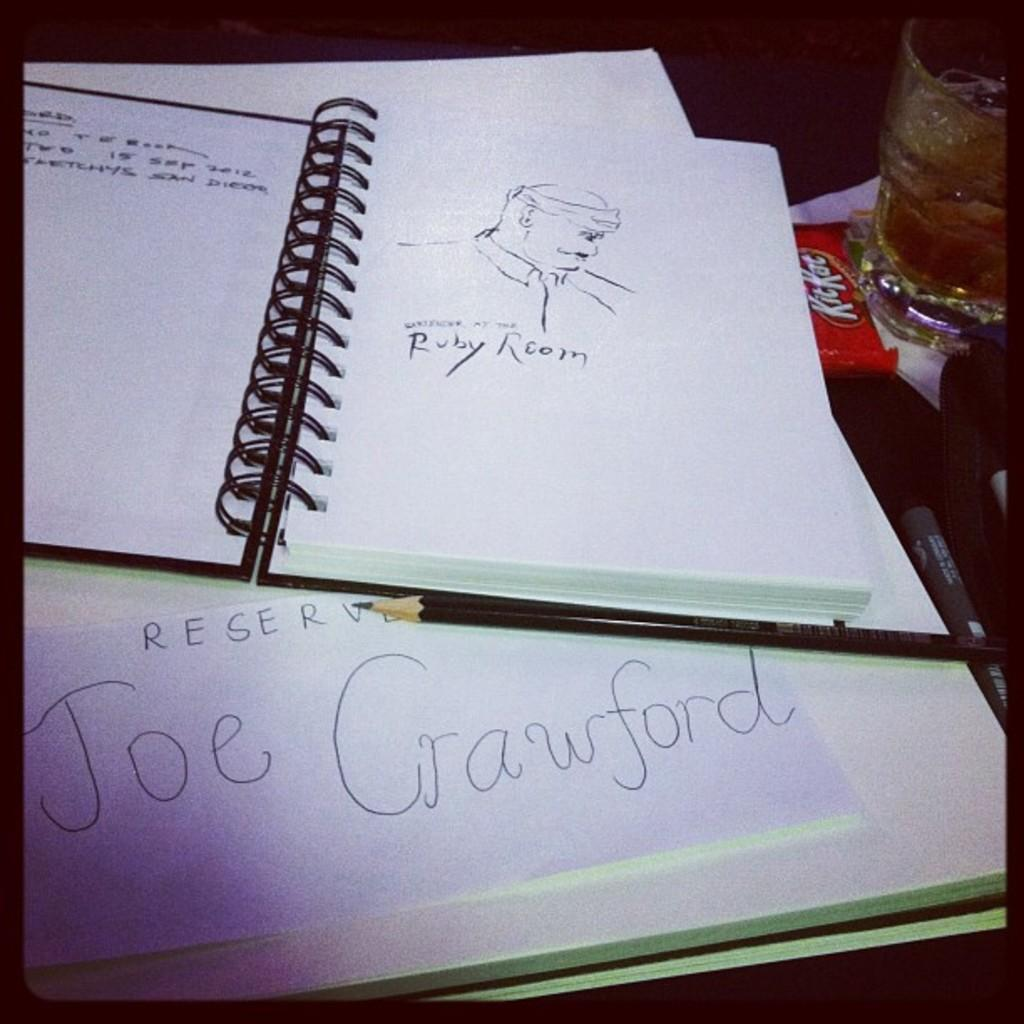Provide a one-sentence caption for the provided image. a spiral drawing book with a drawing by joe crawford. 